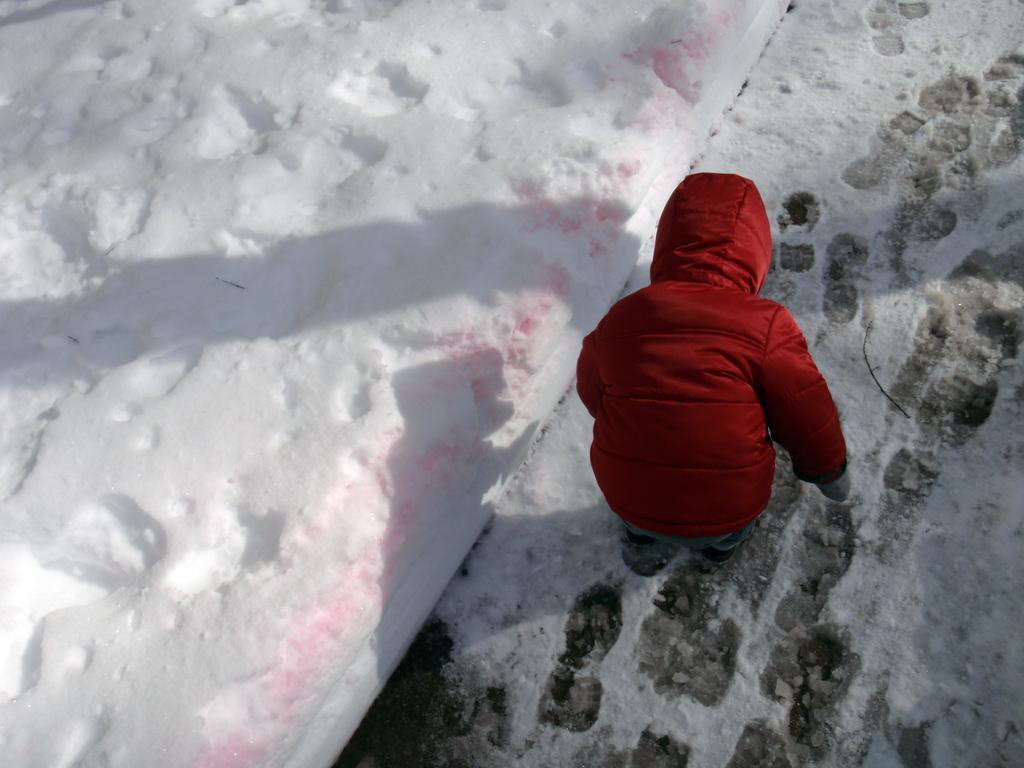Can you describe this image briefly? In this image we can see a kid wearing a jacket and we can see snow. 